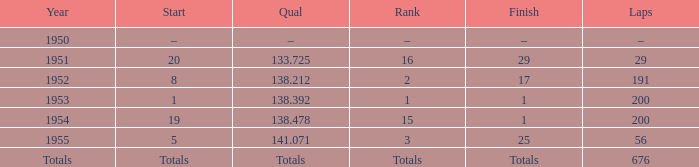What year was the ranking 1? 1953.0. 